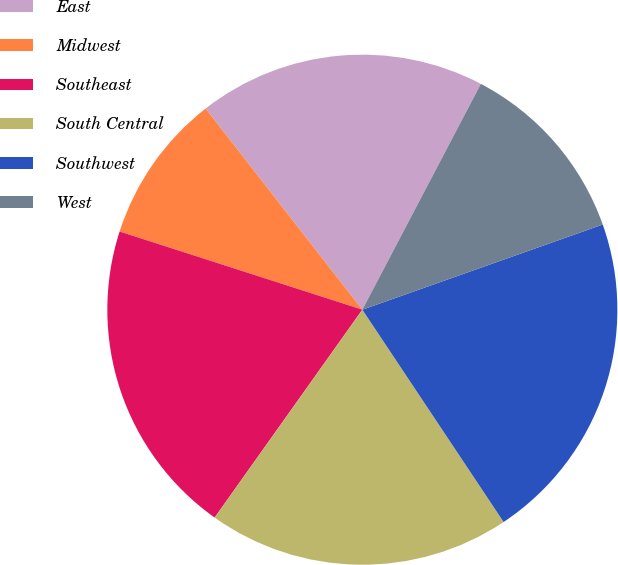<chart> <loc_0><loc_0><loc_500><loc_500><pie_chart><fcel>East<fcel>Midwest<fcel>Southeast<fcel>South Central<fcel>Southwest<fcel>West<nl><fcel>18.23%<fcel>9.51%<fcel>20.13%<fcel>19.18%<fcel>21.08%<fcel>11.89%<nl></chart> 